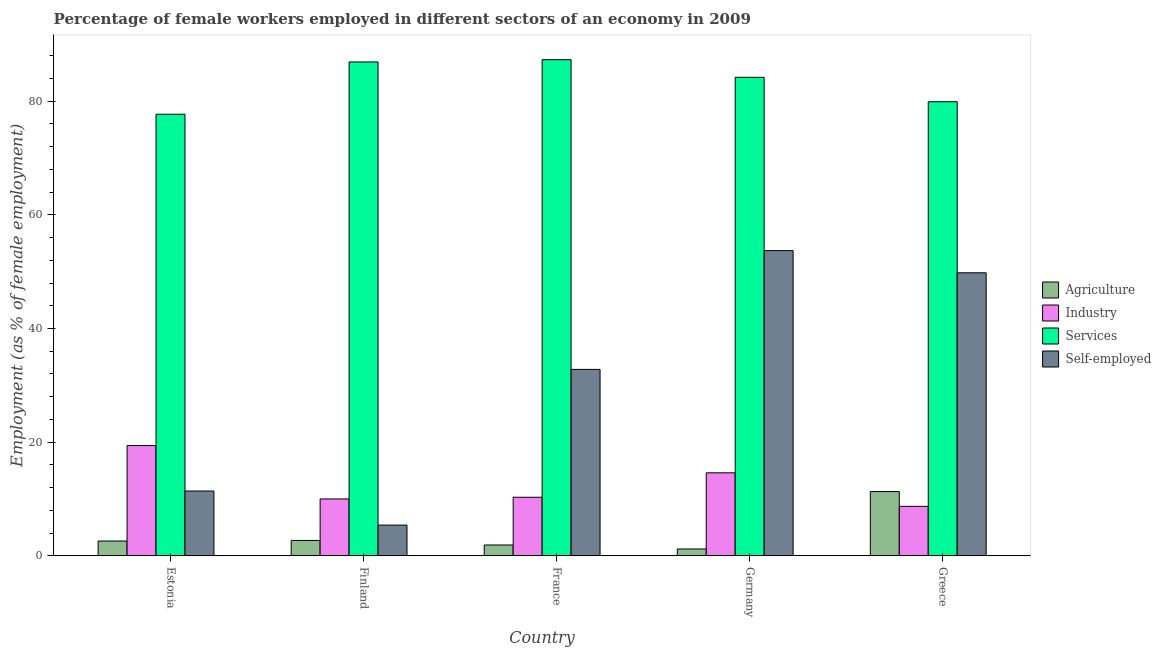How many different coloured bars are there?
Provide a succinct answer. 4. Are the number of bars per tick equal to the number of legend labels?
Make the answer very short. Yes. In how many cases, is the number of bars for a given country not equal to the number of legend labels?
Offer a terse response. 0. What is the percentage of self employed female workers in Greece?
Ensure brevity in your answer.  49.8. Across all countries, what is the maximum percentage of female workers in services?
Give a very brief answer. 87.3. Across all countries, what is the minimum percentage of female workers in agriculture?
Provide a succinct answer. 1.2. In which country was the percentage of self employed female workers maximum?
Provide a succinct answer. Germany. What is the total percentage of self employed female workers in the graph?
Provide a short and direct response. 153.1. What is the difference between the percentage of female workers in industry in France and that in Greece?
Offer a very short reply. 1.6. What is the difference between the percentage of self employed female workers in Germany and the percentage of female workers in services in France?
Offer a terse response. -33.6. What is the average percentage of female workers in services per country?
Offer a very short reply. 83.2. What is the difference between the percentage of female workers in agriculture and percentage of self employed female workers in France?
Make the answer very short. -30.9. What is the ratio of the percentage of self employed female workers in France to that in Greece?
Give a very brief answer. 0.66. Is the percentage of self employed female workers in Germany less than that in Greece?
Provide a short and direct response. No. Is the difference between the percentage of female workers in industry in Finland and Germany greater than the difference between the percentage of female workers in services in Finland and Germany?
Keep it short and to the point. No. What is the difference between the highest and the second highest percentage of female workers in services?
Make the answer very short. 0.4. What is the difference between the highest and the lowest percentage of female workers in industry?
Provide a short and direct response. 10.7. Is the sum of the percentage of female workers in services in Germany and Greece greater than the maximum percentage of self employed female workers across all countries?
Your answer should be very brief. Yes. What does the 1st bar from the left in Greece represents?
Your response must be concise. Agriculture. What does the 3rd bar from the right in Estonia represents?
Your answer should be compact. Industry. How many bars are there?
Keep it short and to the point. 20. Are all the bars in the graph horizontal?
Offer a very short reply. No. Where does the legend appear in the graph?
Your answer should be compact. Center right. How many legend labels are there?
Offer a very short reply. 4. How are the legend labels stacked?
Provide a short and direct response. Vertical. What is the title of the graph?
Keep it short and to the point. Percentage of female workers employed in different sectors of an economy in 2009. Does "Agriculture" appear as one of the legend labels in the graph?
Make the answer very short. Yes. What is the label or title of the Y-axis?
Keep it short and to the point. Employment (as % of female employment). What is the Employment (as % of female employment) in Agriculture in Estonia?
Your answer should be compact. 2.6. What is the Employment (as % of female employment) of Industry in Estonia?
Offer a very short reply. 19.4. What is the Employment (as % of female employment) of Services in Estonia?
Keep it short and to the point. 77.7. What is the Employment (as % of female employment) of Self-employed in Estonia?
Offer a terse response. 11.4. What is the Employment (as % of female employment) of Agriculture in Finland?
Ensure brevity in your answer.  2.7. What is the Employment (as % of female employment) of Services in Finland?
Ensure brevity in your answer.  86.9. What is the Employment (as % of female employment) of Self-employed in Finland?
Make the answer very short. 5.4. What is the Employment (as % of female employment) of Agriculture in France?
Give a very brief answer. 1.9. What is the Employment (as % of female employment) in Industry in France?
Give a very brief answer. 10.3. What is the Employment (as % of female employment) in Services in France?
Make the answer very short. 87.3. What is the Employment (as % of female employment) in Self-employed in France?
Give a very brief answer. 32.8. What is the Employment (as % of female employment) in Agriculture in Germany?
Offer a terse response. 1.2. What is the Employment (as % of female employment) of Industry in Germany?
Make the answer very short. 14.6. What is the Employment (as % of female employment) in Services in Germany?
Keep it short and to the point. 84.2. What is the Employment (as % of female employment) in Self-employed in Germany?
Give a very brief answer. 53.7. What is the Employment (as % of female employment) of Agriculture in Greece?
Offer a very short reply. 11.3. What is the Employment (as % of female employment) of Industry in Greece?
Give a very brief answer. 8.7. What is the Employment (as % of female employment) in Services in Greece?
Ensure brevity in your answer.  79.9. What is the Employment (as % of female employment) in Self-employed in Greece?
Offer a terse response. 49.8. Across all countries, what is the maximum Employment (as % of female employment) of Agriculture?
Provide a succinct answer. 11.3. Across all countries, what is the maximum Employment (as % of female employment) in Industry?
Your answer should be compact. 19.4. Across all countries, what is the maximum Employment (as % of female employment) in Services?
Your answer should be compact. 87.3. Across all countries, what is the maximum Employment (as % of female employment) in Self-employed?
Give a very brief answer. 53.7. Across all countries, what is the minimum Employment (as % of female employment) in Agriculture?
Keep it short and to the point. 1.2. Across all countries, what is the minimum Employment (as % of female employment) in Industry?
Your answer should be compact. 8.7. Across all countries, what is the minimum Employment (as % of female employment) in Services?
Offer a very short reply. 77.7. Across all countries, what is the minimum Employment (as % of female employment) in Self-employed?
Give a very brief answer. 5.4. What is the total Employment (as % of female employment) in Agriculture in the graph?
Offer a terse response. 19.7. What is the total Employment (as % of female employment) of Services in the graph?
Offer a terse response. 416. What is the total Employment (as % of female employment) in Self-employed in the graph?
Provide a short and direct response. 153.1. What is the difference between the Employment (as % of female employment) of Agriculture in Estonia and that in Finland?
Provide a short and direct response. -0.1. What is the difference between the Employment (as % of female employment) in Services in Estonia and that in Finland?
Your response must be concise. -9.2. What is the difference between the Employment (as % of female employment) of Industry in Estonia and that in France?
Provide a short and direct response. 9.1. What is the difference between the Employment (as % of female employment) in Services in Estonia and that in France?
Give a very brief answer. -9.6. What is the difference between the Employment (as % of female employment) in Self-employed in Estonia and that in France?
Provide a succinct answer. -21.4. What is the difference between the Employment (as % of female employment) in Self-employed in Estonia and that in Germany?
Keep it short and to the point. -42.3. What is the difference between the Employment (as % of female employment) in Industry in Estonia and that in Greece?
Your answer should be very brief. 10.7. What is the difference between the Employment (as % of female employment) of Services in Estonia and that in Greece?
Keep it short and to the point. -2.2. What is the difference between the Employment (as % of female employment) of Self-employed in Estonia and that in Greece?
Offer a terse response. -38.4. What is the difference between the Employment (as % of female employment) of Agriculture in Finland and that in France?
Ensure brevity in your answer.  0.8. What is the difference between the Employment (as % of female employment) in Industry in Finland and that in France?
Provide a short and direct response. -0.3. What is the difference between the Employment (as % of female employment) of Self-employed in Finland and that in France?
Your response must be concise. -27.4. What is the difference between the Employment (as % of female employment) of Agriculture in Finland and that in Germany?
Ensure brevity in your answer.  1.5. What is the difference between the Employment (as % of female employment) of Industry in Finland and that in Germany?
Provide a short and direct response. -4.6. What is the difference between the Employment (as % of female employment) in Services in Finland and that in Germany?
Offer a terse response. 2.7. What is the difference between the Employment (as % of female employment) in Self-employed in Finland and that in Germany?
Your answer should be compact. -48.3. What is the difference between the Employment (as % of female employment) of Industry in Finland and that in Greece?
Make the answer very short. 1.3. What is the difference between the Employment (as % of female employment) of Self-employed in Finland and that in Greece?
Your answer should be very brief. -44.4. What is the difference between the Employment (as % of female employment) of Industry in France and that in Germany?
Your answer should be very brief. -4.3. What is the difference between the Employment (as % of female employment) in Self-employed in France and that in Germany?
Offer a very short reply. -20.9. What is the difference between the Employment (as % of female employment) in Agriculture in France and that in Greece?
Ensure brevity in your answer.  -9.4. What is the difference between the Employment (as % of female employment) in Self-employed in France and that in Greece?
Provide a succinct answer. -17. What is the difference between the Employment (as % of female employment) in Agriculture in Germany and that in Greece?
Your response must be concise. -10.1. What is the difference between the Employment (as % of female employment) in Industry in Germany and that in Greece?
Offer a terse response. 5.9. What is the difference between the Employment (as % of female employment) in Services in Germany and that in Greece?
Offer a very short reply. 4.3. What is the difference between the Employment (as % of female employment) in Agriculture in Estonia and the Employment (as % of female employment) in Industry in Finland?
Ensure brevity in your answer.  -7.4. What is the difference between the Employment (as % of female employment) in Agriculture in Estonia and the Employment (as % of female employment) in Services in Finland?
Make the answer very short. -84.3. What is the difference between the Employment (as % of female employment) in Agriculture in Estonia and the Employment (as % of female employment) in Self-employed in Finland?
Ensure brevity in your answer.  -2.8. What is the difference between the Employment (as % of female employment) of Industry in Estonia and the Employment (as % of female employment) of Services in Finland?
Your answer should be very brief. -67.5. What is the difference between the Employment (as % of female employment) of Industry in Estonia and the Employment (as % of female employment) of Self-employed in Finland?
Offer a very short reply. 14. What is the difference between the Employment (as % of female employment) of Services in Estonia and the Employment (as % of female employment) of Self-employed in Finland?
Your answer should be very brief. 72.3. What is the difference between the Employment (as % of female employment) of Agriculture in Estonia and the Employment (as % of female employment) of Services in France?
Offer a terse response. -84.7. What is the difference between the Employment (as % of female employment) in Agriculture in Estonia and the Employment (as % of female employment) in Self-employed in France?
Offer a very short reply. -30.2. What is the difference between the Employment (as % of female employment) of Industry in Estonia and the Employment (as % of female employment) of Services in France?
Give a very brief answer. -67.9. What is the difference between the Employment (as % of female employment) in Services in Estonia and the Employment (as % of female employment) in Self-employed in France?
Make the answer very short. 44.9. What is the difference between the Employment (as % of female employment) in Agriculture in Estonia and the Employment (as % of female employment) in Industry in Germany?
Offer a terse response. -12. What is the difference between the Employment (as % of female employment) of Agriculture in Estonia and the Employment (as % of female employment) of Services in Germany?
Your answer should be compact. -81.6. What is the difference between the Employment (as % of female employment) of Agriculture in Estonia and the Employment (as % of female employment) of Self-employed in Germany?
Give a very brief answer. -51.1. What is the difference between the Employment (as % of female employment) in Industry in Estonia and the Employment (as % of female employment) in Services in Germany?
Keep it short and to the point. -64.8. What is the difference between the Employment (as % of female employment) of Industry in Estonia and the Employment (as % of female employment) of Self-employed in Germany?
Make the answer very short. -34.3. What is the difference between the Employment (as % of female employment) of Agriculture in Estonia and the Employment (as % of female employment) of Services in Greece?
Make the answer very short. -77.3. What is the difference between the Employment (as % of female employment) of Agriculture in Estonia and the Employment (as % of female employment) of Self-employed in Greece?
Your answer should be compact. -47.2. What is the difference between the Employment (as % of female employment) in Industry in Estonia and the Employment (as % of female employment) in Services in Greece?
Ensure brevity in your answer.  -60.5. What is the difference between the Employment (as % of female employment) of Industry in Estonia and the Employment (as % of female employment) of Self-employed in Greece?
Ensure brevity in your answer.  -30.4. What is the difference between the Employment (as % of female employment) of Services in Estonia and the Employment (as % of female employment) of Self-employed in Greece?
Make the answer very short. 27.9. What is the difference between the Employment (as % of female employment) of Agriculture in Finland and the Employment (as % of female employment) of Industry in France?
Your answer should be very brief. -7.6. What is the difference between the Employment (as % of female employment) of Agriculture in Finland and the Employment (as % of female employment) of Services in France?
Your answer should be compact. -84.6. What is the difference between the Employment (as % of female employment) in Agriculture in Finland and the Employment (as % of female employment) in Self-employed in France?
Provide a succinct answer. -30.1. What is the difference between the Employment (as % of female employment) of Industry in Finland and the Employment (as % of female employment) of Services in France?
Give a very brief answer. -77.3. What is the difference between the Employment (as % of female employment) in Industry in Finland and the Employment (as % of female employment) in Self-employed in France?
Make the answer very short. -22.8. What is the difference between the Employment (as % of female employment) of Services in Finland and the Employment (as % of female employment) of Self-employed in France?
Provide a succinct answer. 54.1. What is the difference between the Employment (as % of female employment) of Agriculture in Finland and the Employment (as % of female employment) of Services in Germany?
Provide a succinct answer. -81.5. What is the difference between the Employment (as % of female employment) of Agriculture in Finland and the Employment (as % of female employment) of Self-employed in Germany?
Give a very brief answer. -51. What is the difference between the Employment (as % of female employment) in Industry in Finland and the Employment (as % of female employment) in Services in Germany?
Ensure brevity in your answer.  -74.2. What is the difference between the Employment (as % of female employment) of Industry in Finland and the Employment (as % of female employment) of Self-employed in Germany?
Give a very brief answer. -43.7. What is the difference between the Employment (as % of female employment) of Services in Finland and the Employment (as % of female employment) of Self-employed in Germany?
Offer a very short reply. 33.2. What is the difference between the Employment (as % of female employment) in Agriculture in Finland and the Employment (as % of female employment) in Industry in Greece?
Your answer should be compact. -6. What is the difference between the Employment (as % of female employment) of Agriculture in Finland and the Employment (as % of female employment) of Services in Greece?
Ensure brevity in your answer.  -77.2. What is the difference between the Employment (as % of female employment) in Agriculture in Finland and the Employment (as % of female employment) in Self-employed in Greece?
Make the answer very short. -47.1. What is the difference between the Employment (as % of female employment) of Industry in Finland and the Employment (as % of female employment) of Services in Greece?
Provide a short and direct response. -69.9. What is the difference between the Employment (as % of female employment) of Industry in Finland and the Employment (as % of female employment) of Self-employed in Greece?
Provide a short and direct response. -39.8. What is the difference between the Employment (as % of female employment) of Services in Finland and the Employment (as % of female employment) of Self-employed in Greece?
Make the answer very short. 37.1. What is the difference between the Employment (as % of female employment) in Agriculture in France and the Employment (as % of female employment) in Services in Germany?
Provide a succinct answer. -82.3. What is the difference between the Employment (as % of female employment) of Agriculture in France and the Employment (as % of female employment) of Self-employed in Germany?
Your answer should be very brief. -51.8. What is the difference between the Employment (as % of female employment) in Industry in France and the Employment (as % of female employment) in Services in Germany?
Provide a short and direct response. -73.9. What is the difference between the Employment (as % of female employment) in Industry in France and the Employment (as % of female employment) in Self-employed in Germany?
Your answer should be very brief. -43.4. What is the difference between the Employment (as % of female employment) in Services in France and the Employment (as % of female employment) in Self-employed in Germany?
Keep it short and to the point. 33.6. What is the difference between the Employment (as % of female employment) of Agriculture in France and the Employment (as % of female employment) of Services in Greece?
Ensure brevity in your answer.  -78. What is the difference between the Employment (as % of female employment) in Agriculture in France and the Employment (as % of female employment) in Self-employed in Greece?
Make the answer very short. -47.9. What is the difference between the Employment (as % of female employment) in Industry in France and the Employment (as % of female employment) in Services in Greece?
Give a very brief answer. -69.6. What is the difference between the Employment (as % of female employment) in Industry in France and the Employment (as % of female employment) in Self-employed in Greece?
Provide a succinct answer. -39.5. What is the difference between the Employment (as % of female employment) of Services in France and the Employment (as % of female employment) of Self-employed in Greece?
Ensure brevity in your answer.  37.5. What is the difference between the Employment (as % of female employment) of Agriculture in Germany and the Employment (as % of female employment) of Industry in Greece?
Your response must be concise. -7.5. What is the difference between the Employment (as % of female employment) of Agriculture in Germany and the Employment (as % of female employment) of Services in Greece?
Offer a very short reply. -78.7. What is the difference between the Employment (as % of female employment) of Agriculture in Germany and the Employment (as % of female employment) of Self-employed in Greece?
Provide a short and direct response. -48.6. What is the difference between the Employment (as % of female employment) in Industry in Germany and the Employment (as % of female employment) in Services in Greece?
Offer a terse response. -65.3. What is the difference between the Employment (as % of female employment) of Industry in Germany and the Employment (as % of female employment) of Self-employed in Greece?
Offer a terse response. -35.2. What is the difference between the Employment (as % of female employment) of Services in Germany and the Employment (as % of female employment) of Self-employed in Greece?
Offer a very short reply. 34.4. What is the average Employment (as % of female employment) in Agriculture per country?
Your response must be concise. 3.94. What is the average Employment (as % of female employment) in Services per country?
Offer a very short reply. 83.2. What is the average Employment (as % of female employment) of Self-employed per country?
Keep it short and to the point. 30.62. What is the difference between the Employment (as % of female employment) of Agriculture and Employment (as % of female employment) of Industry in Estonia?
Your response must be concise. -16.8. What is the difference between the Employment (as % of female employment) in Agriculture and Employment (as % of female employment) in Services in Estonia?
Provide a succinct answer. -75.1. What is the difference between the Employment (as % of female employment) in Industry and Employment (as % of female employment) in Services in Estonia?
Keep it short and to the point. -58.3. What is the difference between the Employment (as % of female employment) of Services and Employment (as % of female employment) of Self-employed in Estonia?
Provide a succinct answer. 66.3. What is the difference between the Employment (as % of female employment) in Agriculture and Employment (as % of female employment) in Industry in Finland?
Make the answer very short. -7.3. What is the difference between the Employment (as % of female employment) in Agriculture and Employment (as % of female employment) in Services in Finland?
Ensure brevity in your answer.  -84.2. What is the difference between the Employment (as % of female employment) of Industry and Employment (as % of female employment) of Services in Finland?
Keep it short and to the point. -76.9. What is the difference between the Employment (as % of female employment) in Services and Employment (as % of female employment) in Self-employed in Finland?
Make the answer very short. 81.5. What is the difference between the Employment (as % of female employment) in Agriculture and Employment (as % of female employment) in Industry in France?
Provide a succinct answer. -8.4. What is the difference between the Employment (as % of female employment) in Agriculture and Employment (as % of female employment) in Services in France?
Ensure brevity in your answer.  -85.4. What is the difference between the Employment (as % of female employment) of Agriculture and Employment (as % of female employment) of Self-employed in France?
Make the answer very short. -30.9. What is the difference between the Employment (as % of female employment) of Industry and Employment (as % of female employment) of Services in France?
Keep it short and to the point. -77. What is the difference between the Employment (as % of female employment) in Industry and Employment (as % of female employment) in Self-employed in France?
Offer a very short reply. -22.5. What is the difference between the Employment (as % of female employment) in Services and Employment (as % of female employment) in Self-employed in France?
Keep it short and to the point. 54.5. What is the difference between the Employment (as % of female employment) of Agriculture and Employment (as % of female employment) of Industry in Germany?
Offer a terse response. -13.4. What is the difference between the Employment (as % of female employment) of Agriculture and Employment (as % of female employment) of Services in Germany?
Provide a succinct answer. -83. What is the difference between the Employment (as % of female employment) in Agriculture and Employment (as % of female employment) in Self-employed in Germany?
Make the answer very short. -52.5. What is the difference between the Employment (as % of female employment) in Industry and Employment (as % of female employment) in Services in Germany?
Make the answer very short. -69.6. What is the difference between the Employment (as % of female employment) of Industry and Employment (as % of female employment) of Self-employed in Germany?
Provide a short and direct response. -39.1. What is the difference between the Employment (as % of female employment) of Services and Employment (as % of female employment) of Self-employed in Germany?
Provide a succinct answer. 30.5. What is the difference between the Employment (as % of female employment) of Agriculture and Employment (as % of female employment) of Services in Greece?
Your response must be concise. -68.6. What is the difference between the Employment (as % of female employment) in Agriculture and Employment (as % of female employment) in Self-employed in Greece?
Your answer should be compact. -38.5. What is the difference between the Employment (as % of female employment) in Industry and Employment (as % of female employment) in Services in Greece?
Offer a very short reply. -71.2. What is the difference between the Employment (as % of female employment) of Industry and Employment (as % of female employment) of Self-employed in Greece?
Your response must be concise. -41.1. What is the difference between the Employment (as % of female employment) in Services and Employment (as % of female employment) in Self-employed in Greece?
Give a very brief answer. 30.1. What is the ratio of the Employment (as % of female employment) in Agriculture in Estonia to that in Finland?
Keep it short and to the point. 0.96. What is the ratio of the Employment (as % of female employment) of Industry in Estonia to that in Finland?
Ensure brevity in your answer.  1.94. What is the ratio of the Employment (as % of female employment) in Services in Estonia to that in Finland?
Offer a terse response. 0.89. What is the ratio of the Employment (as % of female employment) of Self-employed in Estonia to that in Finland?
Your answer should be compact. 2.11. What is the ratio of the Employment (as % of female employment) of Agriculture in Estonia to that in France?
Offer a very short reply. 1.37. What is the ratio of the Employment (as % of female employment) in Industry in Estonia to that in France?
Your answer should be very brief. 1.88. What is the ratio of the Employment (as % of female employment) of Services in Estonia to that in France?
Provide a succinct answer. 0.89. What is the ratio of the Employment (as % of female employment) in Self-employed in Estonia to that in France?
Offer a very short reply. 0.35. What is the ratio of the Employment (as % of female employment) in Agriculture in Estonia to that in Germany?
Ensure brevity in your answer.  2.17. What is the ratio of the Employment (as % of female employment) in Industry in Estonia to that in Germany?
Ensure brevity in your answer.  1.33. What is the ratio of the Employment (as % of female employment) of Services in Estonia to that in Germany?
Provide a succinct answer. 0.92. What is the ratio of the Employment (as % of female employment) of Self-employed in Estonia to that in Germany?
Give a very brief answer. 0.21. What is the ratio of the Employment (as % of female employment) of Agriculture in Estonia to that in Greece?
Offer a terse response. 0.23. What is the ratio of the Employment (as % of female employment) in Industry in Estonia to that in Greece?
Ensure brevity in your answer.  2.23. What is the ratio of the Employment (as % of female employment) of Services in Estonia to that in Greece?
Your answer should be compact. 0.97. What is the ratio of the Employment (as % of female employment) in Self-employed in Estonia to that in Greece?
Your response must be concise. 0.23. What is the ratio of the Employment (as % of female employment) in Agriculture in Finland to that in France?
Your answer should be compact. 1.42. What is the ratio of the Employment (as % of female employment) of Industry in Finland to that in France?
Make the answer very short. 0.97. What is the ratio of the Employment (as % of female employment) of Services in Finland to that in France?
Your answer should be very brief. 1. What is the ratio of the Employment (as % of female employment) in Self-employed in Finland to that in France?
Your response must be concise. 0.16. What is the ratio of the Employment (as % of female employment) in Agriculture in Finland to that in Germany?
Your answer should be compact. 2.25. What is the ratio of the Employment (as % of female employment) in Industry in Finland to that in Germany?
Your response must be concise. 0.68. What is the ratio of the Employment (as % of female employment) of Services in Finland to that in Germany?
Offer a terse response. 1.03. What is the ratio of the Employment (as % of female employment) in Self-employed in Finland to that in Germany?
Ensure brevity in your answer.  0.1. What is the ratio of the Employment (as % of female employment) of Agriculture in Finland to that in Greece?
Offer a terse response. 0.24. What is the ratio of the Employment (as % of female employment) of Industry in Finland to that in Greece?
Provide a succinct answer. 1.15. What is the ratio of the Employment (as % of female employment) in Services in Finland to that in Greece?
Your answer should be compact. 1.09. What is the ratio of the Employment (as % of female employment) of Self-employed in Finland to that in Greece?
Make the answer very short. 0.11. What is the ratio of the Employment (as % of female employment) of Agriculture in France to that in Germany?
Provide a short and direct response. 1.58. What is the ratio of the Employment (as % of female employment) of Industry in France to that in Germany?
Your answer should be compact. 0.71. What is the ratio of the Employment (as % of female employment) of Services in France to that in Germany?
Your response must be concise. 1.04. What is the ratio of the Employment (as % of female employment) in Self-employed in France to that in Germany?
Give a very brief answer. 0.61. What is the ratio of the Employment (as % of female employment) of Agriculture in France to that in Greece?
Offer a very short reply. 0.17. What is the ratio of the Employment (as % of female employment) of Industry in France to that in Greece?
Provide a short and direct response. 1.18. What is the ratio of the Employment (as % of female employment) of Services in France to that in Greece?
Offer a very short reply. 1.09. What is the ratio of the Employment (as % of female employment) of Self-employed in France to that in Greece?
Offer a very short reply. 0.66. What is the ratio of the Employment (as % of female employment) of Agriculture in Germany to that in Greece?
Keep it short and to the point. 0.11. What is the ratio of the Employment (as % of female employment) of Industry in Germany to that in Greece?
Keep it short and to the point. 1.68. What is the ratio of the Employment (as % of female employment) of Services in Germany to that in Greece?
Your answer should be compact. 1.05. What is the ratio of the Employment (as % of female employment) in Self-employed in Germany to that in Greece?
Offer a terse response. 1.08. What is the difference between the highest and the second highest Employment (as % of female employment) of Industry?
Offer a terse response. 4.8. What is the difference between the highest and the second highest Employment (as % of female employment) of Self-employed?
Provide a succinct answer. 3.9. What is the difference between the highest and the lowest Employment (as % of female employment) of Agriculture?
Offer a very short reply. 10.1. What is the difference between the highest and the lowest Employment (as % of female employment) in Industry?
Make the answer very short. 10.7. What is the difference between the highest and the lowest Employment (as % of female employment) in Services?
Offer a terse response. 9.6. What is the difference between the highest and the lowest Employment (as % of female employment) in Self-employed?
Offer a terse response. 48.3. 